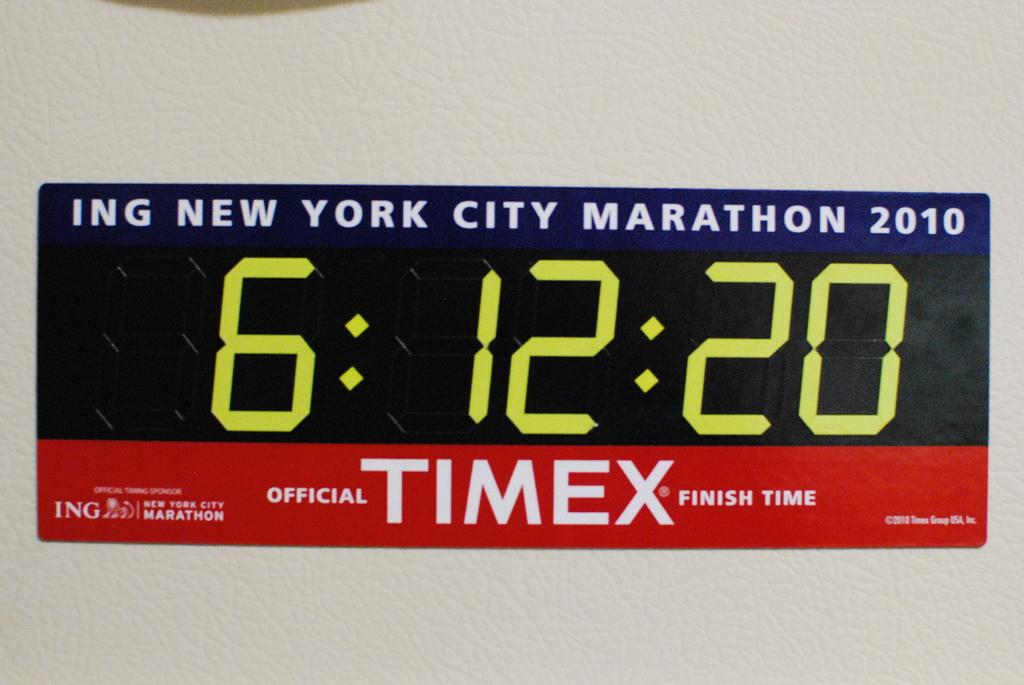What is the primary color of the surface in the image? The primary color of the surface in the image is white. What is placed on the white surface? There is a sticker on the white surface. What can be found on the sticker? The sticker has words and numbers on it. What type of can is depicted on the sticker? There is no can depicted on the sticker; it only has words and numbers on it. 